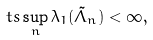Convert formula to latex. <formula><loc_0><loc_0><loc_500><loc_500>\ t s \sup _ { n } \lambda _ { 1 } ( \tilde { \Lambda } _ { n } ) < \infty ,</formula> 